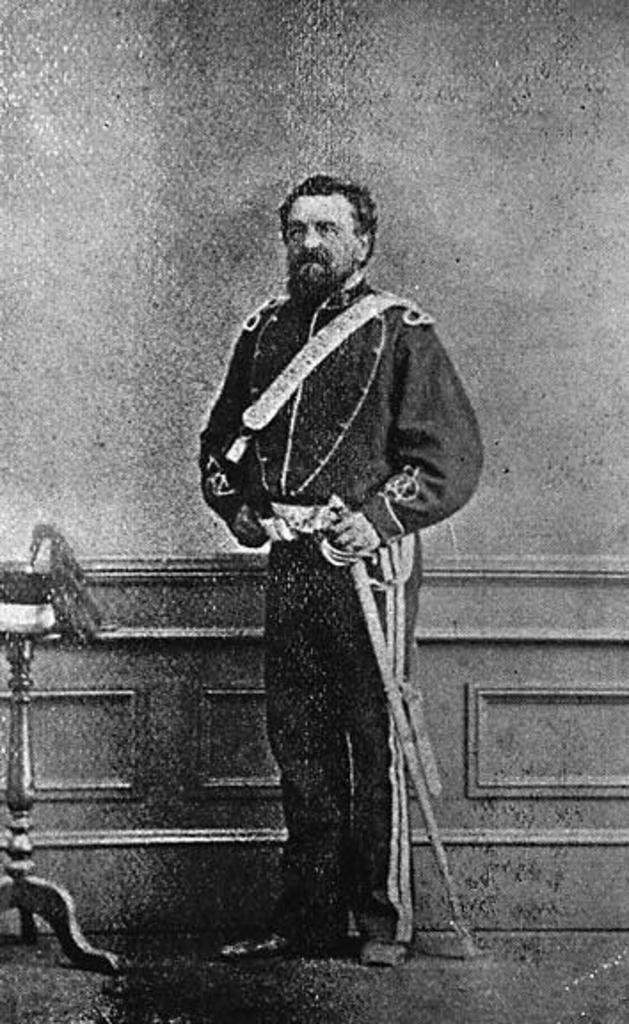What is the color scheme of the image? The image is black and white. Can you describe the person in the image? There is a person standing in the image. Where is the person standing? The person is standing on the floor. What is located beside the person? There is a stand beside the person. What can be seen in the background of the image? There is a wall in the background of the image. How does the person paste the wall in the image? There is no indication in the image that the person is pasting anything on the wall. 